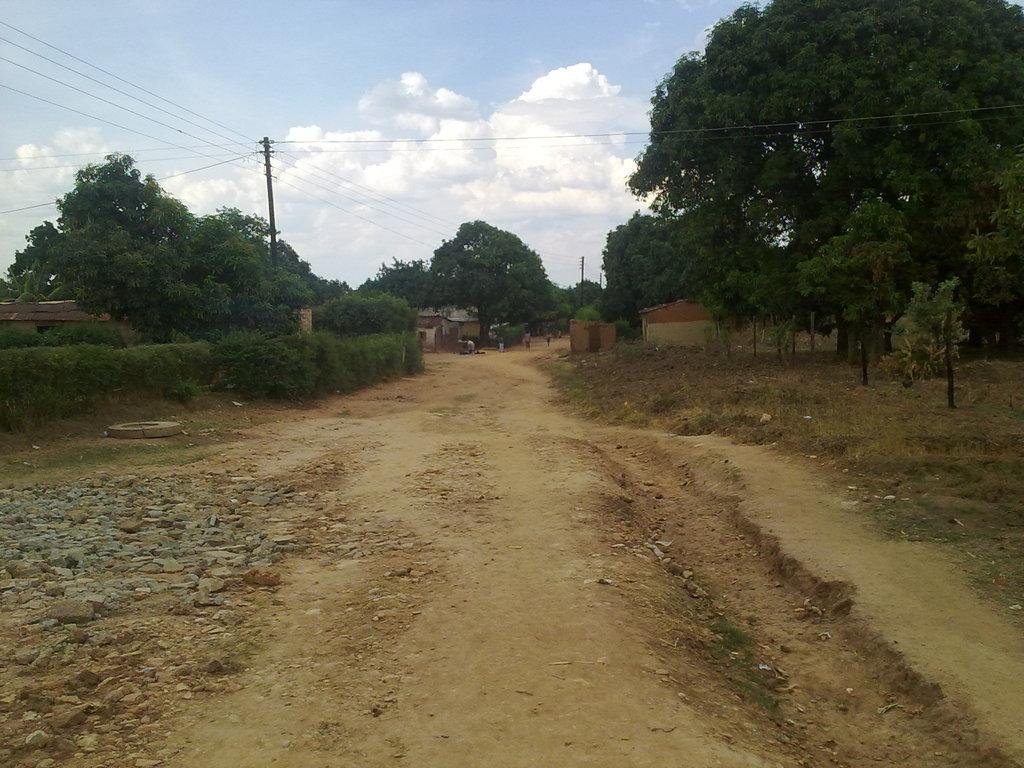What can be seen running through the center of the image? There is a path in the image. What type of vegetation is present alongside the path? Plants and trees are present on either side of the path. What structures can be seen in the background of the image? There are houses in the background of the image. What type of infrastructure is visible in the background of the image? Current poles are visible in the background of the image. What is visible at the top of the image? The sky is visible in the background of the image. What type of ray is swimming in the image? There is no ray present in the image; it features a path with plants, trees, houses, current poles, and a sky. What type of porter is carrying luggage in the image? There is no porter present in the image; it features a path with plants, trees, houses, current poles, and a sky. 